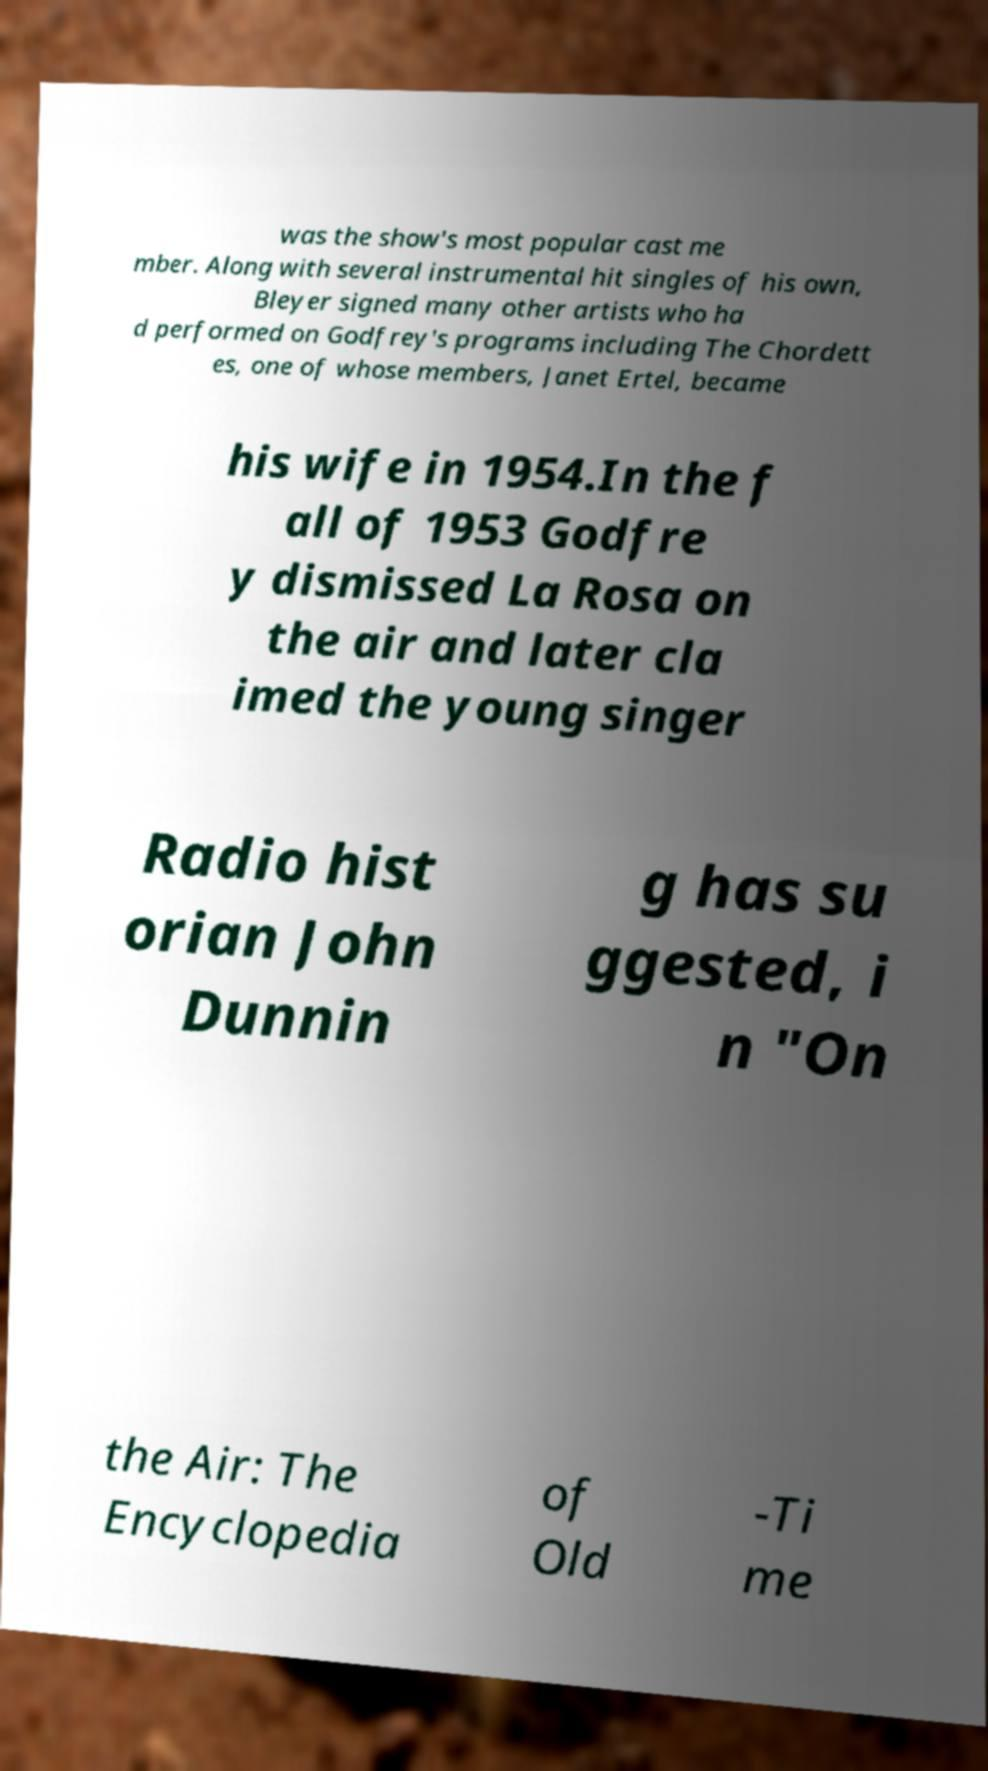Please identify and transcribe the text found in this image. was the show's most popular cast me mber. Along with several instrumental hit singles of his own, Bleyer signed many other artists who ha d performed on Godfrey's programs including The Chordett es, one of whose members, Janet Ertel, became his wife in 1954.In the f all of 1953 Godfre y dismissed La Rosa on the air and later cla imed the young singer Radio hist orian John Dunnin g has su ggested, i n "On the Air: The Encyclopedia of Old -Ti me 